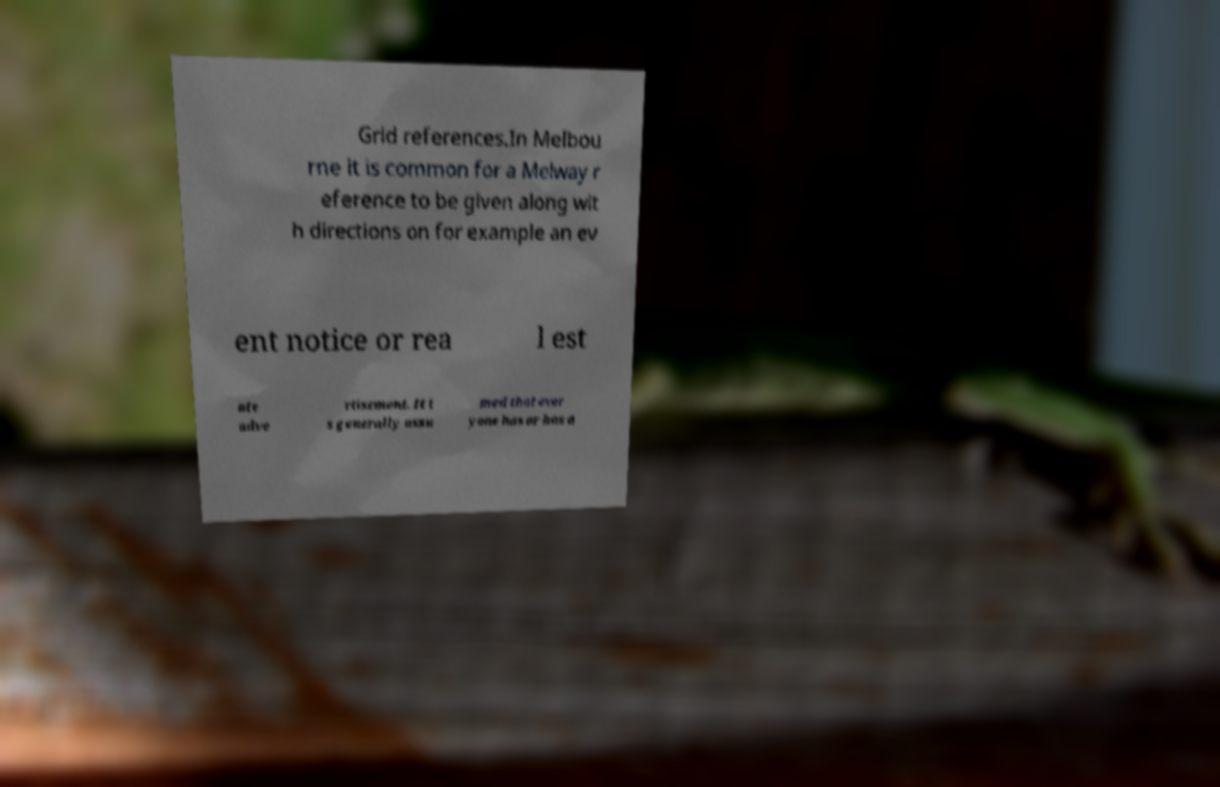Could you assist in decoding the text presented in this image and type it out clearly? Grid references.In Melbou rne it is common for a Melway r eference to be given along wit h directions on for example an ev ent notice or rea l est ate adve rtisement. It i s generally assu med that ever yone has or has a 